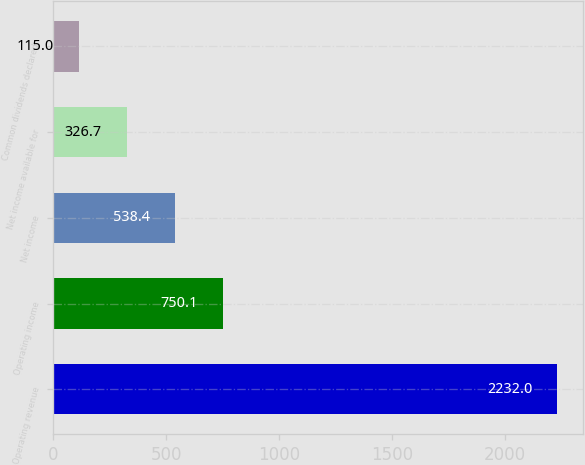Convert chart to OTSL. <chart><loc_0><loc_0><loc_500><loc_500><bar_chart><fcel>Operating revenue<fcel>Operating income<fcel>Net income<fcel>Net income available for<fcel>Common dividends declared<nl><fcel>2232<fcel>750.1<fcel>538.4<fcel>326.7<fcel>115<nl></chart> 